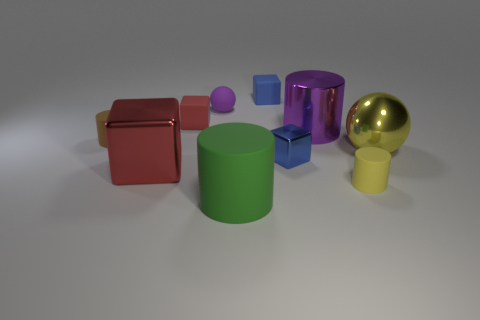Subtract all yellow cylinders. How many cylinders are left? 3 Subtract 1 cubes. How many cubes are left? 3 Subtract all yellow cylinders. How many cylinders are left? 3 Subtract all blocks. How many objects are left? 6 Subtract all small blue balls. Subtract all big red shiny cubes. How many objects are left? 9 Add 6 red shiny cubes. How many red shiny cubes are left? 7 Add 8 large blue things. How many large blue things exist? 8 Subtract 0 purple blocks. How many objects are left? 10 Subtract all blue balls. Subtract all purple cylinders. How many balls are left? 2 Subtract all brown cylinders. How many blue blocks are left? 2 